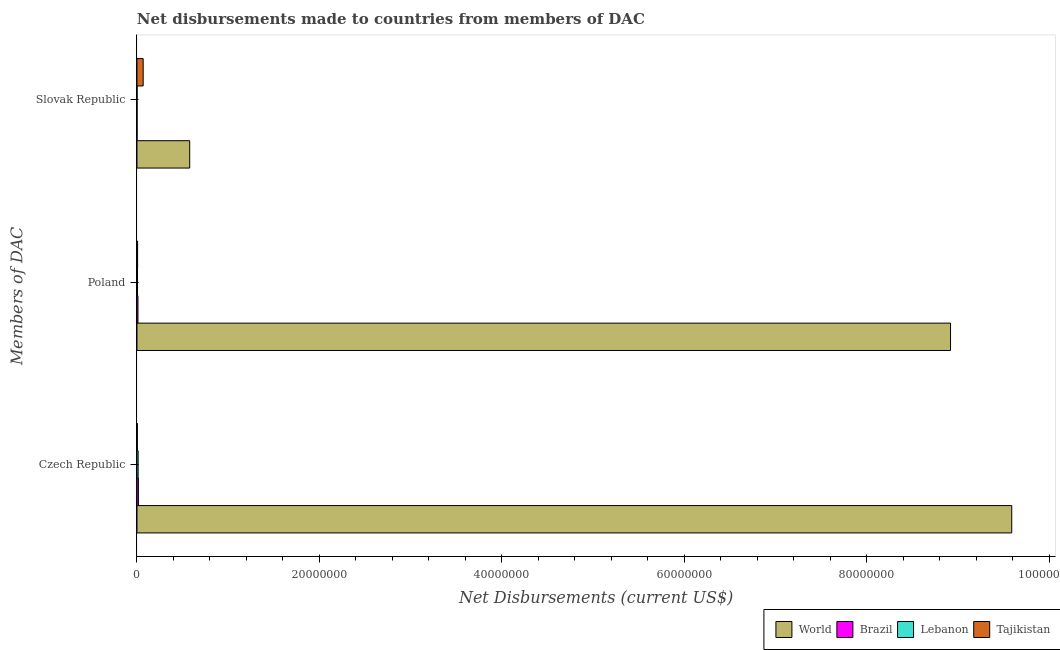How many different coloured bars are there?
Your answer should be very brief. 4. Are the number of bars per tick equal to the number of legend labels?
Provide a succinct answer. Yes. How many bars are there on the 2nd tick from the top?
Give a very brief answer. 4. What is the label of the 2nd group of bars from the top?
Your response must be concise. Poland. What is the net disbursements made by czech republic in Brazil?
Provide a succinct answer. 1.60e+05. Across all countries, what is the maximum net disbursements made by poland?
Provide a short and direct response. 8.92e+07. Across all countries, what is the minimum net disbursements made by slovak republic?
Your answer should be compact. 10000. In which country was the net disbursements made by poland maximum?
Your answer should be compact. World. In which country was the net disbursements made by czech republic minimum?
Provide a succinct answer. Tajikistan. What is the total net disbursements made by poland in the graph?
Keep it short and to the point. 8.94e+07. What is the difference between the net disbursements made by slovak republic in Tajikistan and that in Lebanon?
Ensure brevity in your answer.  6.70e+05. What is the difference between the net disbursements made by slovak republic in Tajikistan and the net disbursements made by poland in Brazil?
Your answer should be compact. 5.70e+05. What is the average net disbursements made by slovak republic per country?
Your response must be concise. 1.62e+06. What is the difference between the net disbursements made by poland and net disbursements made by czech republic in Lebanon?
Your answer should be very brief. -7.00e+04. In how many countries, is the net disbursements made by slovak republic greater than 56000000 US$?
Provide a succinct answer. 0. What is the ratio of the net disbursements made by slovak republic in Brazil to that in Tajikistan?
Offer a very short reply. 0.01. What is the difference between the highest and the second highest net disbursements made by slovak republic?
Offer a very short reply. 5.10e+06. What is the difference between the highest and the lowest net disbursements made by poland?
Provide a short and direct response. 8.91e+07. In how many countries, is the net disbursements made by czech republic greater than the average net disbursements made by czech republic taken over all countries?
Provide a short and direct response. 1. Is the sum of the net disbursements made by czech republic in Lebanon and Brazil greater than the maximum net disbursements made by slovak republic across all countries?
Give a very brief answer. No. What does the 1st bar from the top in Slovak Republic represents?
Offer a terse response. Tajikistan. Is it the case that in every country, the sum of the net disbursements made by czech republic and net disbursements made by poland is greater than the net disbursements made by slovak republic?
Your response must be concise. No. How many bars are there?
Your response must be concise. 12. Are all the bars in the graph horizontal?
Your response must be concise. Yes. Does the graph contain any zero values?
Your response must be concise. No. Where does the legend appear in the graph?
Offer a very short reply. Bottom right. How many legend labels are there?
Make the answer very short. 4. What is the title of the graph?
Offer a very short reply. Net disbursements made to countries from members of DAC. What is the label or title of the X-axis?
Ensure brevity in your answer.  Net Disbursements (current US$). What is the label or title of the Y-axis?
Make the answer very short. Members of DAC. What is the Net Disbursements (current US$) of World in Czech Republic?
Make the answer very short. 9.59e+07. What is the Net Disbursements (current US$) of Brazil in Czech Republic?
Your answer should be compact. 1.60e+05. What is the Net Disbursements (current US$) of Lebanon in Czech Republic?
Give a very brief answer. 1.30e+05. What is the Net Disbursements (current US$) of Tajikistan in Czech Republic?
Offer a terse response. 4.00e+04. What is the Net Disbursements (current US$) in World in Poland?
Your response must be concise. 8.92e+07. What is the Net Disbursements (current US$) of Lebanon in Poland?
Make the answer very short. 6.00e+04. What is the Net Disbursements (current US$) in World in Slovak Republic?
Provide a succinct answer. 5.78e+06. What is the Net Disbursements (current US$) in Brazil in Slovak Republic?
Provide a short and direct response. 10000. What is the Net Disbursements (current US$) in Tajikistan in Slovak Republic?
Ensure brevity in your answer.  6.80e+05. Across all Members of DAC, what is the maximum Net Disbursements (current US$) of World?
Keep it short and to the point. 9.59e+07. Across all Members of DAC, what is the maximum Net Disbursements (current US$) of Brazil?
Your answer should be very brief. 1.60e+05. Across all Members of DAC, what is the maximum Net Disbursements (current US$) in Tajikistan?
Offer a very short reply. 6.80e+05. Across all Members of DAC, what is the minimum Net Disbursements (current US$) of World?
Give a very brief answer. 5.78e+06. Across all Members of DAC, what is the minimum Net Disbursements (current US$) of Brazil?
Provide a succinct answer. 10000. Across all Members of DAC, what is the minimum Net Disbursements (current US$) of Lebanon?
Offer a very short reply. 10000. Across all Members of DAC, what is the minimum Net Disbursements (current US$) in Tajikistan?
Your answer should be compact. 4.00e+04. What is the total Net Disbursements (current US$) in World in the graph?
Offer a terse response. 1.91e+08. What is the total Net Disbursements (current US$) in Lebanon in the graph?
Your answer should be compact. 2.00e+05. What is the total Net Disbursements (current US$) in Tajikistan in the graph?
Offer a very short reply. 7.90e+05. What is the difference between the Net Disbursements (current US$) in World in Czech Republic and that in Poland?
Offer a terse response. 6.71e+06. What is the difference between the Net Disbursements (current US$) of Brazil in Czech Republic and that in Poland?
Ensure brevity in your answer.  5.00e+04. What is the difference between the Net Disbursements (current US$) of Lebanon in Czech Republic and that in Poland?
Your answer should be compact. 7.00e+04. What is the difference between the Net Disbursements (current US$) in World in Czech Republic and that in Slovak Republic?
Provide a succinct answer. 9.01e+07. What is the difference between the Net Disbursements (current US$) of Brazil in Czech Republic and that in Slovak Republic?
Offer a very short reply. 1.50e+05. What is the difference between the Net Disbursements (current US$) of Lebanon in Czech Republic and that in Slovak Republic?
Your response must be concise. 1.20e+05. What is the difference between the Net Disbursements (current US$) of Tajikistan in Czech Republic and that in Slovak Republic?
Offer a very short reply. -6.40e+05. What is the difference between the Net Disbursements (current US$) in World in Poland and that in Slovak Republic?
Provide a succinct answer. 8.34e+07. What is the difference between the Net Disbursements (current US$) of Tajikistan in Poland and that in Slovak Republic?
Ensure brevity in your answer.  -6.10e+05. What is the difference between the Net Disbursements (current US$) of World in Czech Republic and the Net Disbursements (current US$) of Brazil in Poland?
Make the answer very short. 9.58e+07. What is the difference between the Net Disbursements (current US$) of World in Czech Republic and the Net Disbursements (current US$) of Lebanon in Poland?
Give a very brief answer. 9.58e+07. What is the difference between the Net Disbursements (current US$) in World in Czech Republic and the Net Disbursements (current US$) in Tajikistan in Poland?
Offer a very short reply. 9.58e+07. What is the difference between the Net Disbursements (current US$) of Brazil in Czech Republic and the Net Disbursements (current US$) of Tajikistan in Poland?
Your response must be concise. 9.00e+04. What is the difference between the Net Disbursements (current US$) of Lebanon in Czech Republic and the Net Disbursements (current US$) of Tajikistan in Poland?
Give a very brief answer. 6.00e+04. What is the difference between the Net Disbursements (current US$) in World in Czech Republic and the Net Disbursements (current US$) in Brazil in Slovak Republic?
Provide a short and direct response. 9.59e+07. What is the difference between the Net Disbursements (current US$) in World in Czech Republic and the Net Disbursements (current US$) in Lebanon in Slovak Republic?
Your response must be concise. 9.59e+07. What is the difference between the Net Disbursements (current US$) of World in Czech Republic and the Net Disbursements (current US$) of Tajikistan in Slovak Republic?
Your answer should be compact. 9.52e+07. What is the difference between the Net Disbursements (current US$) of Brazil in Czech Republic and the Net Disbursements (current US$) of Lebanon in Slovak Republic?
Provide a succinct answer. 1.50e+05. What is the difference between the Net Disbursements (current US$) in Brazil in Czech Republic and the Net Disbursements (current US$) in Tajikistan in Slovak Republic?
Keep it short and to the point. -5.20e+05. What is the difference between the Net Disbursements (current US$) of Lebanon in Czech Republic and the Net Disbursements (current US$) of Tajikistan in Slovak Republic?
Your response must be concise. -5.50e+05. What is the difference between the Net Disbursements (current US$) of World in Poland and the Net Disbursements (current US$) of Brazil in Slovak Republic?
Your answer should be compact. 8.92e+07. What is the difference between the Net Disbursements (current US$) of World in Poland and the Net Disbursements (current US$) of Lebanon in Slovak Republic?
Offer a very short reply. 8.92e+07. What is the difference between the Net Disbursements (current US$) in World in Poland and the Net Disbursements (current US$) in Tajikistan in Slovak Republic?
Give a very brief answer. 8.85e+07. What is the difference between the Net Disbursements (current US$) in Brazil in Poland and the Net Disbursements (current US$) in Tajikistan in Slovak Republic?
Provide a short and direct response. -5.70e+05. What is the difference between the Net Disbursements (current US$) in Lebanon in Poland and the Net Disbursements (current US$) in Tajikistan in Slovak Republic?
Give a very brief answer. -6.20e+05. What is the average Net Disbursements (current US$) in World per Members of DAC?
Ensure brevity in your answer.  6.36e+07. What is the average Net Disbursements (current US$) in Brazil per Members of DAC?
Provide a succinct answer. 9.33e+04. What is the average Net Disbursements (current US$) of Lebanon per Members of DAC?
Keep it short and to the point. 6.67e+04. What is the average Net Disbursements (current US$) in Tajikistan per Members of DAC?
Offer a terse response. 2.63e+05. What is the difference between the Net Disbursements (current US$) in World and Net Disbursements (current US$) in Brazil in Czech Republic?
Make the answer very short. 9.57e+07. What is the difference between the Net Disbursements (current US$) in World and Net Disbursements (current US$) in Lebanon in Czech Republic?
Ensure brevity in your answer.  9.58e+07. What is the difference between the Net Disbursements (current US$) of World and Net Disbursements (current US$) of Tajikistan in Czech Republic?
Keep it short and to the point. 9.58e+07. What is the difference between the Net Disbursements (current US$) in Brazil and Net Disbursements (current US$) in Lebanon in Czech Republic?
Your answer should be compact. 3.00e+04. What is the difference between the Net Disbursements (current US$) in World and Net Disbursements (current US$) in Brazil in Poland?
Keep it short and to the point. 8.91e+07. What is the difference between the Net Disbursements (current US$) of World and Net Disbursements (current US$) of Lebanon in Poland?
Keep it short and to the point. 8.91e+07. What is the difference between the Net Disbursements (current US$) of World and Net Disbursements (current US$) of Tajikistan in Poland?
Your response must be concise. 8.91e+07. What is the difference between the Net Disbursements (current US$) of Brazil and Net Disbursements (current US$) of Lebanon in Poland?
Give a very brief answer. 5.00e+04. What is the difference between the Net Disbursements (current US$) in Brazil and Net Disbursements (current US$) in Tajikistan in Poland?
Your answer should be very brief. 4.00e+04. What is the difference between the Net Disbursements (current US$) in World and Net Disbursements (current US$) in Brazil in Slovak Republic?
Offer a very short reply. 5.77e+06. What is the difference between the Net Disbursements (current US$) in World and Net Disbursements (current US$) in Lebanon in Slovak Republic?
Ensure brevity in your answer.  5.77e+06. What is the difference between the Net Disbursements (current US$) of World and Net Disbursements (current US$) of Tajikistan in Slovak Republic?
Your response must be concise. 5.10e+06. What is the difference between the Net Disbursements (current US$) in Brazil and Net Disbursements (current US$) in Tajikistan in Slovak Republic?
Your response must be concise. -6.70e+05. What is the difference between the Net Disbursements (current US$) of Lebanon and Net Disbursements (current US$) of Tajikistan in Slovak Republic?
Your answer should be compact. -6.70e+05. What is the ratio of the Net Disbursements (current US$) in World in Czech Republic to that in Poland?
Your answer should be compact. 1.08. What is the ratio of the Net Disbursements (current US$) in Brazil in Czech Republic to that in Poland?
Give a very brief answer. 1.45. What is the ratio of the Net Disbursements (current US$) in Lebanon in Czech Republic to that in Poland?
Your response must be concise. 2.17. What is the ratio of the Net Disbursements (current US$) in World in Czech Republic to that in Slovak Republic?
Make the answer very short. 16.59. What is the ratio of the Net Disbursements (current US$) in Lebanon in Czech Republic to that in Slovak Republic?
Your answer should be very brief. 13. What is the ratio of the Net Disbursements (current US$) in Tajikistan in Czech Republic to that in Slovak Republic?
Offer a very short reply. 0.06. What is the ratio of the Net Disbursements (current US$) in World in Poland to that in Slovak Republic?
Your answer should be very brief. 15.43. What is the ratio of the Net Disbursements (current US$) of Tajikistan in Poland to that in Slovak Republic?
Offer a very short reply. 0.1. What is the difference between the highest and the second highest Net Disbursements (current US$) of World?
Offer a very short reply. 6.71e+06. What is the difference between the highest and the lowest Net Disbursements (current US$) in World?
Ensure brevity in your answer.  9.01e+07. What is the difference between the highest and the lowest Net Disbursements (current US$) in Lebanon?
Your answer should be compact. 1.20e+05. What is the difference between the highest and the lowest Net Disbursements (current US$) in Tajikistan?
Keep it short and to the point. 6.40e+05. 